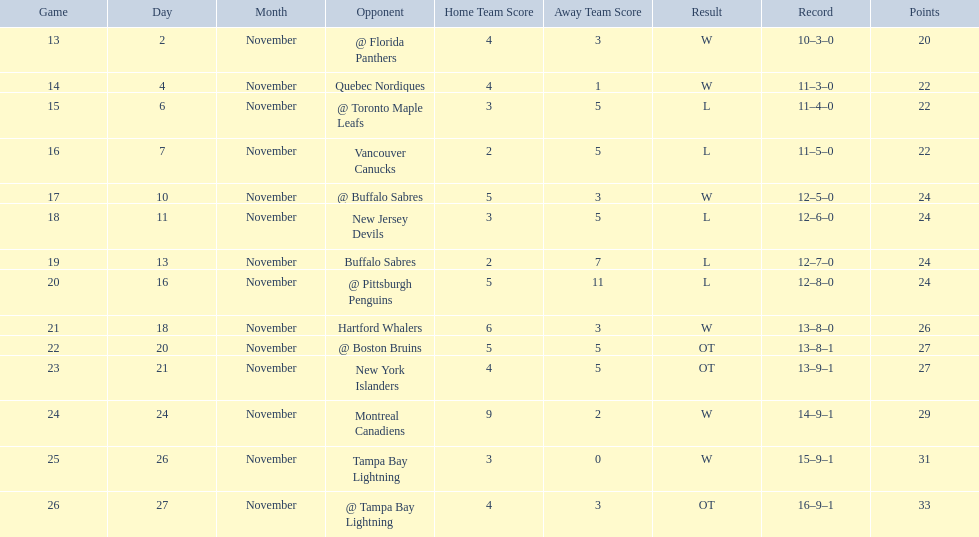What were the scores of the 1993-94 philadelphia flyers season? 4–3, 4–1, 3–5, 2–5, 5–3, 3–5, 2–7, 5–11, 6–3, 5–5 OT, 4–5 OT, 9–2, 3–0, 4–3 OT. Which of these teams had the score 4-5 ot? New York Islanders. 